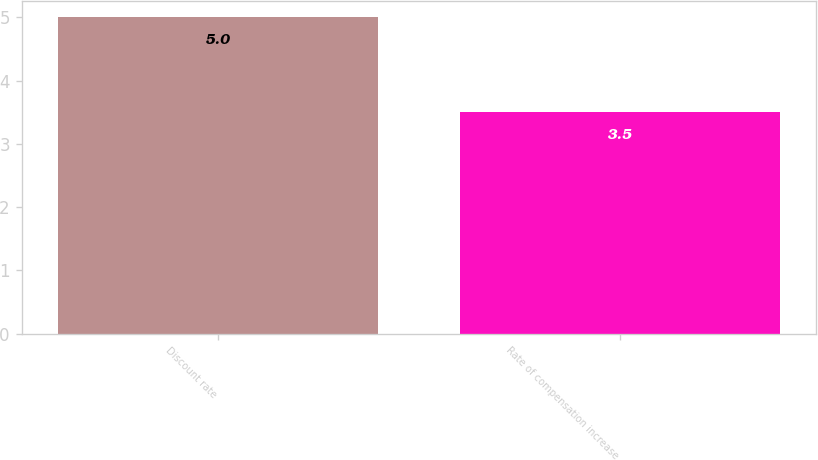Convert chart. <chart><loc_0><loc_0><loc_500><loc_500><bar_chart><fcel>Discount rate<fcel>Rate of compensation increase<nl><fcel>5<fcel>3.5<nl></chart> 